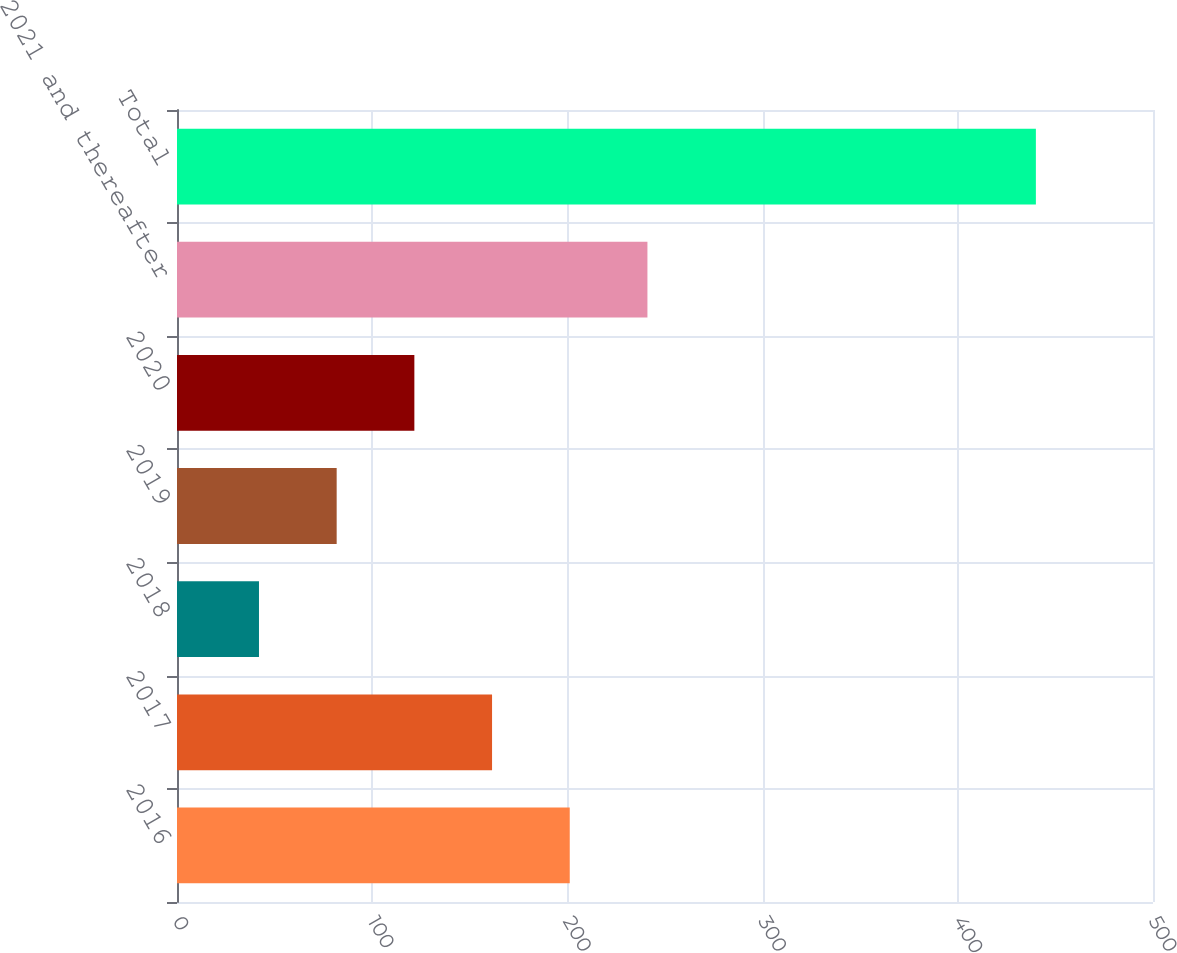Convert chart to OTSL. <chart><loc_0><loc_0><loc_500><loc_500><bar_chart><fcel>2016<fcel>2017<fcel>2018<fcel>2019<fcel>2020<fcel>2021 and thereafter<fcel>Total<nl><fcel>201.2<fcel>161.4<fcel>42<fcel>81.8<fcel>121.6<fcel>241<fcel>440<nl></chart> 